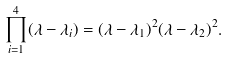Convert formula to latex. <formula><loc_0><loc_0><loc_500><loc_500>\prod _ { i = 1 } ^ { 4 } ( \lambda - \lambda _ { i } ) = ( \lambda - \lambda _ { 1 } ) ^ { 2 } ( \lambda - \lambda _ { 2 } ) ^ { 2 } .</formula> 